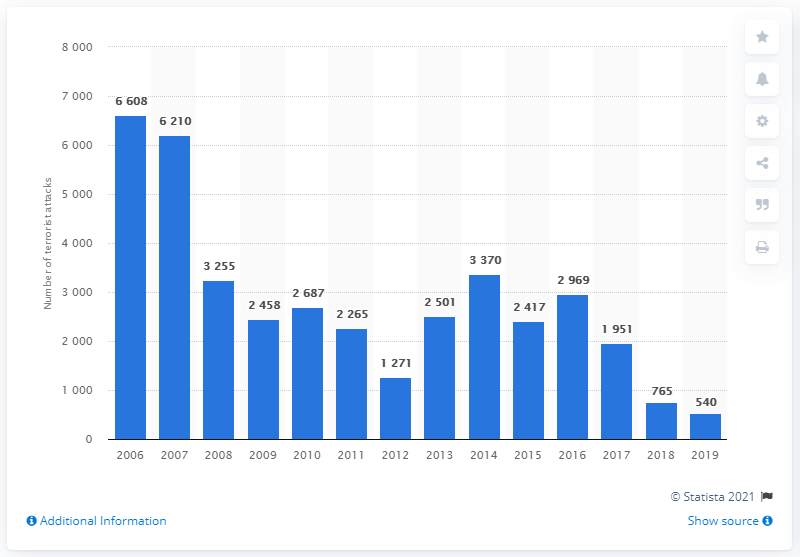Outline some significant characteristics in this image. In 2006, approximately 6,608 terrorist attacks occurred in Iraq. 